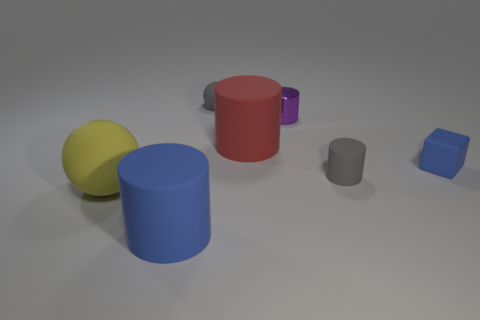Add 1 gray cylinders. How many objects exist? 8 Subtract all blocks. How many objects are left? 6 Subtract 0 cyan cylinders. How many objects are left? 7 Subtract all tiny blue matte cubes. Subtract all yellow matte spheres. How many objects are left? 5 Add 2 big rubber things. How many big rubber things are left? 5 Add 6 gray matte balls. How many gray matte balls exist? 7 